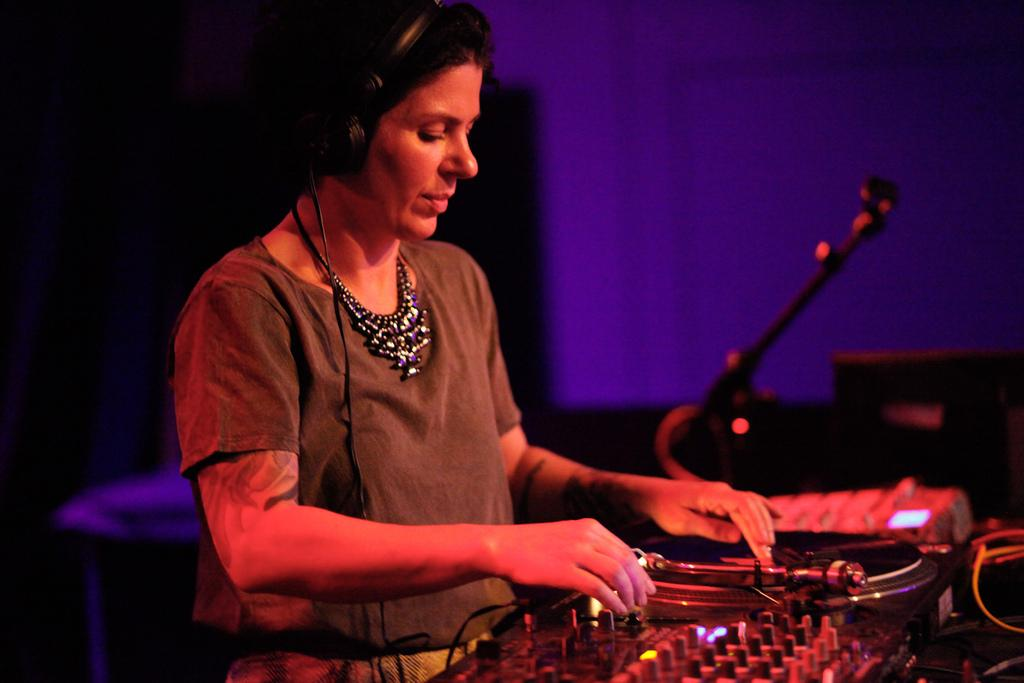Who is present in the image? There is a woman in the image. What is the woman doing in the image? The woman is standing near a DJ pioneer. What is the woman wearing in the image? The woman is wearing a headset. What can be seen in the background of the image? There is a blue color wall in the image. What objects are on the floor in the image? There are objects on the floor in the image. What equipment is associated with the DJ pioneer in the image? There is a DJ pioneer controller box in the image. What type of nest can be seen in the image? There is no nest present in the image. What kind of skirt is the woman wearing in the image? The woman is not wearing a skirt in the image; she is wearing a headset. 